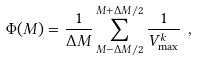<formula> <loc_0><loc_0><loc_500><loc_500>\Phi ( M ) = \frac { 1 } { \Delta M } \sum _ { M - \Delta M / 2 } ^ { M + \Delta M / 2 } \frac { 1 } { V _ { \max } ^ { k } } \ ,</formula> 